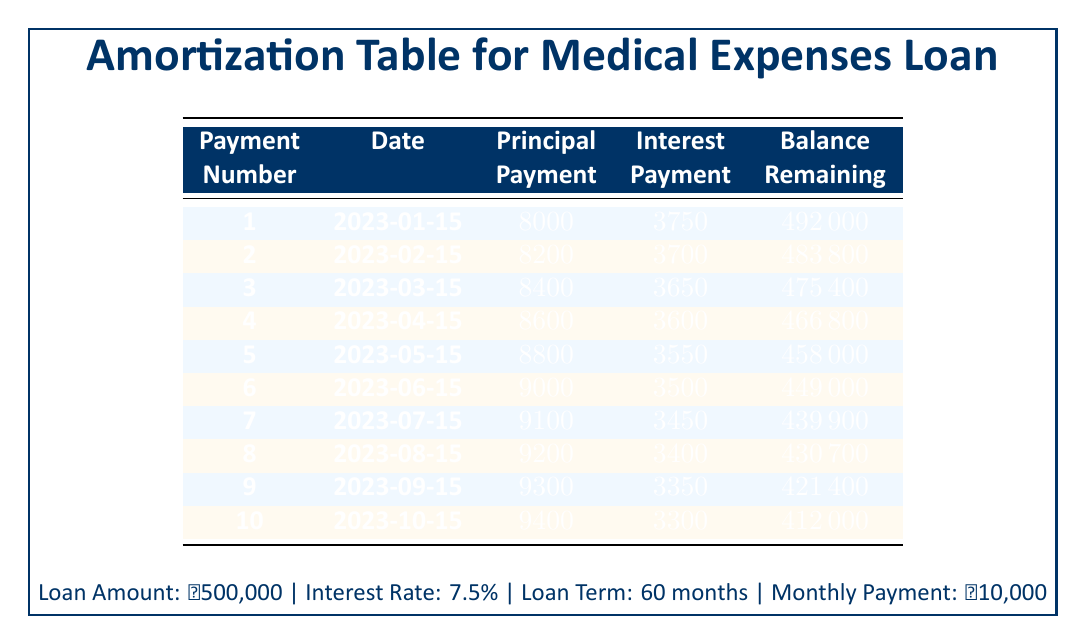What is the principal amount paid in the first payment? The first payment's principal amount is listed in the table under the "Principal Payment" column corresponding to Payment Number 1. It shows that the principal payment made was 8000.
Answer: 8000 How much interest was paid in the second payment? The second payment's interest amount is provided in the table under the "Interest Payment" column for Payment Number 2. The table states that the interest payment was 3700.
Answer: 3700 What is the remaining balance after the fifth payment? The remaining balance after the fifth payment can be found in the "Remaining Balance" column next to Payment Number 5. It indicates that the remaining balance is 458000.
Answer: 458000 What was the total principal payment made in the first three payments? To find the total principal payment of the first three payments, we add together the principal payments from Payment Number 1, 2, and 3: 8000 + 8200 + 8400 = 24600.
Answer: 24600 Is the interest payment for the tenth payment higher than the interest payment for the ninth payment? To answer this, we need to compare the interest payments for Payment Number 10 and Payment Number 9. The interest payment for Payment Number 10 is 3300 and for Payment Number 9 is 3350. Since 3300 is less than 3350, the statement is false.
Answer: No What is the average principal payment across all ten payments? To find the average principal payment, we sum the principal payments from all ten payments (8000 + 8200 + 8400 + 8600 + 8800 + 9000 + 9100 + 9200 + 9300 + 9400 = 91000) and divide by 10 (91000 / 10 = 9100).
Answer: 9100 How much total interest was paid by the end of the tenth payment? To calculate the total interest paid by the end of the tenth payment, we sum the interest payments from each payment (3750 + 3700 + 3650 + 3600 + 3550 + 3500 + 3450 + 3400 + 3350 + 3300 = 35000).
Answer: 35000 What is the remaining balance after the seventh payment compared to the remaining balance after the sixth payment? According to the table, the remaining balance after the seventh payment is 439900, while after the sixth payment, it is 449000. This indicates that the remaining balance decreased by 9100 (449000 - 439900 = 9100).
Answer: 9100 Did the principal payment for the eighth payment exceed the principal payment for the third payment? From the table, the principal payment for Payment Number 8 is 9200, and for Payment Number 3, it is 8400. Since 9200 is greater than 8400, this statement is true.
Answer: Yes 